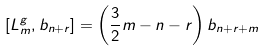<formula> <loc_0><loc_0><loc_500><loc_500>\left [ L _ { m } ^ { g } , b _ { n + r } \right ] = \left ( \frac { 3 } { 2 } m - n - r \right ) b _ { n + r + m }</formula> 